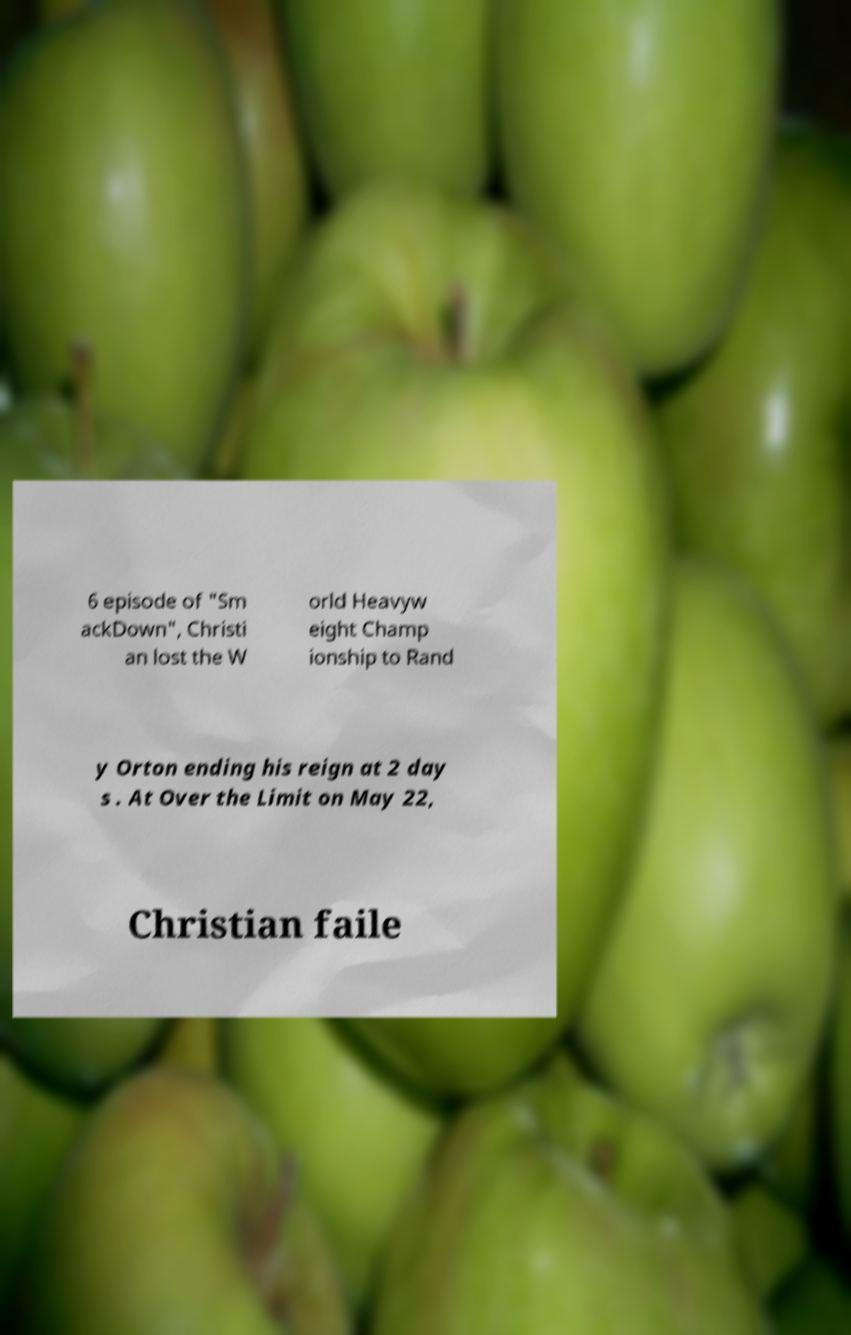Can you read and provide the text displayed in the image?This photo seems to have some interesting text. Can you extract and type it out for me? 6 episode of "Sm ackDown", Christi an lost the W orld Heavyw eight Champ ionship to Rand y Orton ending his reign at 2 day s . At Over the Limit on May 22, Christian faile 